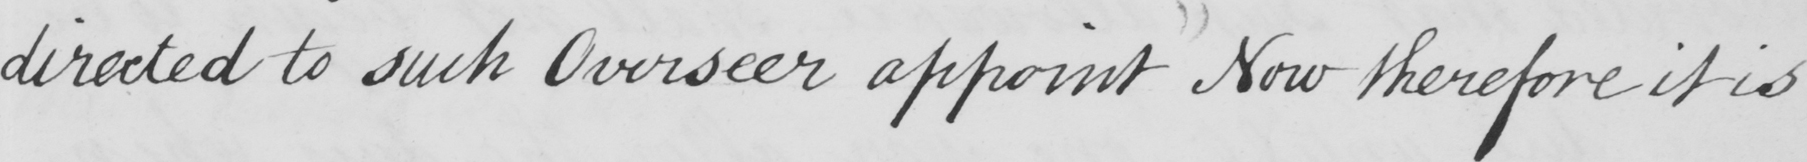What does this handwritten line say? directed to such Overseer appoint now therefore it is 